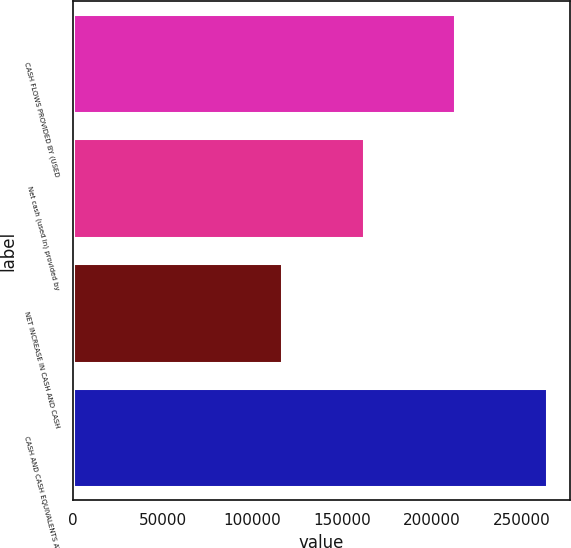Convert chart. <chart><loc_0><loc_0><loc_500><loc_500><bar_chart><fcel>CASH FLOWS PROVIDED BY (USED<fcel>Net cash (used in) provided by<fcel>NET INCREASE IN CASH AND CASH<fcel>CASH AND CASH EQUIVALENTS AT<nl><fcel>212841<fcel>162151<fcel>116711<fcel>264121<nl></chart> 